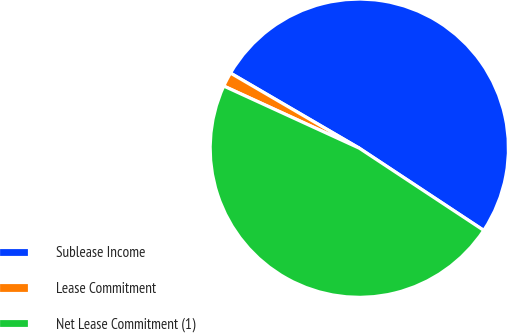Convert chart to OTSL. <chart><loc_0><loc_0><loc_500><loc_500><pie_chart><fcel>Sublease Income<fcel>Lease Commitment<fcel>Net Lease Commitment (1)<nl><fcel>50.89%<fcel>1.56%<fcel>47.55%<nl></chart> 